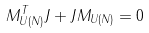Convert formula to latex. <formula><loc_0><loc_0><loc_500><loc_500>M _ { U ( N ) } ^ { T } { J } + { J } M _ { U ( N ) } = 0</formula> 